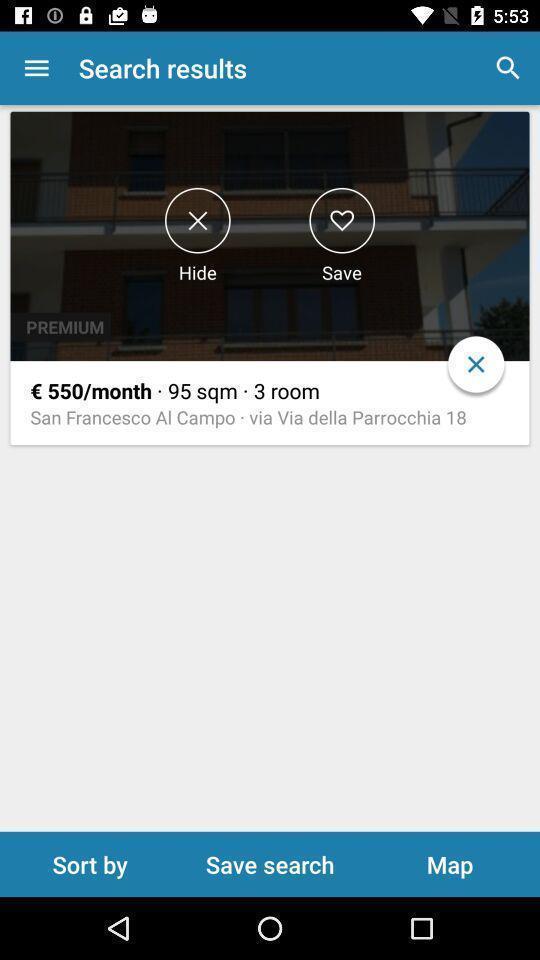Give me a summary of this screen capture. Screen page showing various options. 